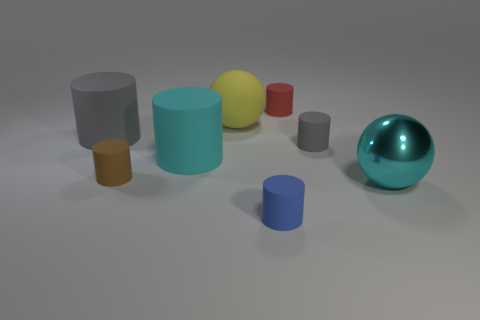What number of big rubber cylinders are the same color as the large shiny thing?
Make the answer very short. 1. There is a metallic object; does it have the same color as the big cylinder that is right of the brown cylinder?
Give a very brief answer. Yes. Do the large rubber cylinder right of the tiny brown rubber cylinder and the large metal object have the same color?
Your answer should be very brief. Yes. Are there any other things that have the same color as the metallic object?
Keep it short and to the point. Yes. What is the shape of the large thing that is the same color as the shiny sphere?
Provide a succinct answer. Cylinder. What number of gray rubber objects are the same shape as the blue object?
Your answer should be compact. 2. What size is the blue cylinder that is the same material as the small gray cylinder?
Your response must be concise. Small. Do the blue matte cylinder and the yellow rubber ball have the same size?
Ensure brevity in your answer.  No. Is there a large red ball?
Offer a very short reply. No. There is a ball behind the big cyan object right of the blue thing that is to the right of the large cyan rubber thing; what size is it?
Keep it short and to the point. Large. 